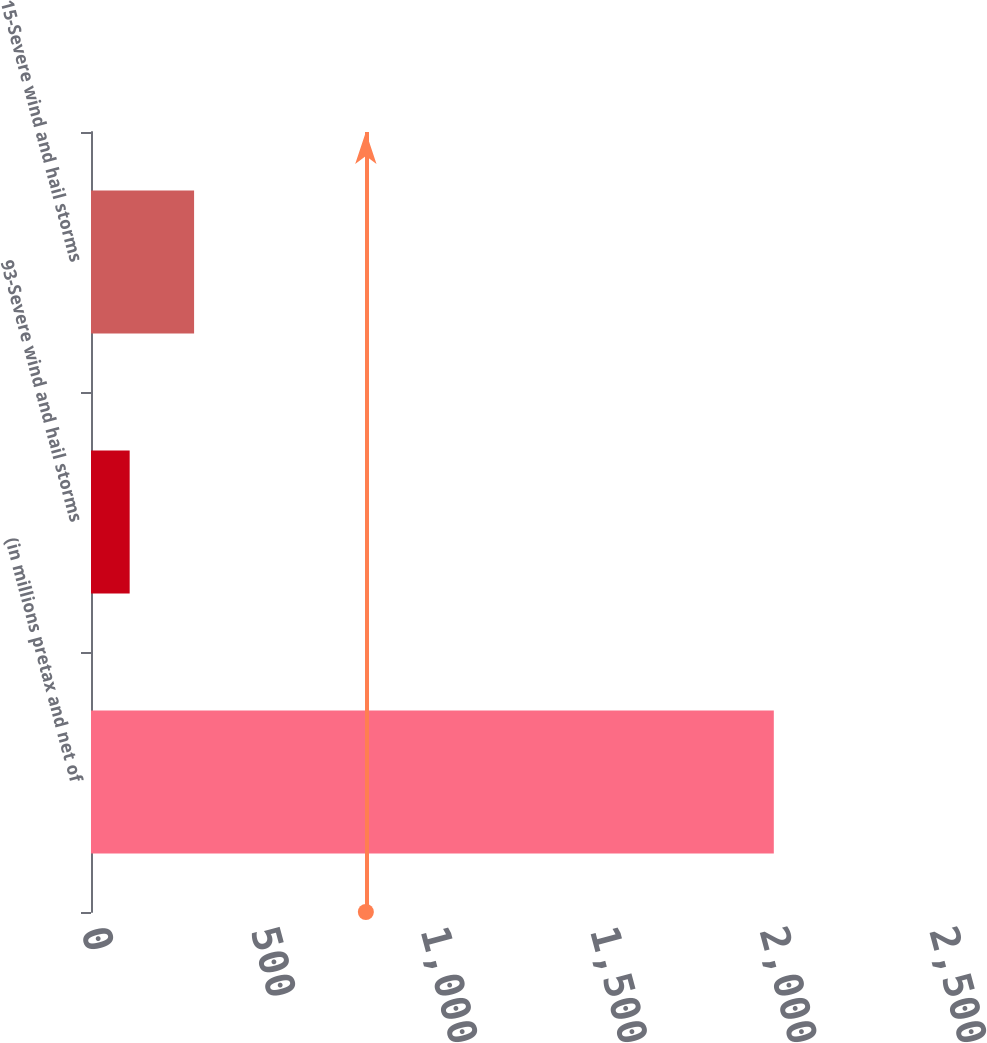<chart> <loc_0><loc_0><loc_500><loc_500><bar_chart><fcel>(in millions pretax and net of<fcel>93-Severe wind and hail storms<fcel>15-Severe wind and hail storms<nl><fcel>2013<fcel>114<fcel>303.9<nl></chart> 